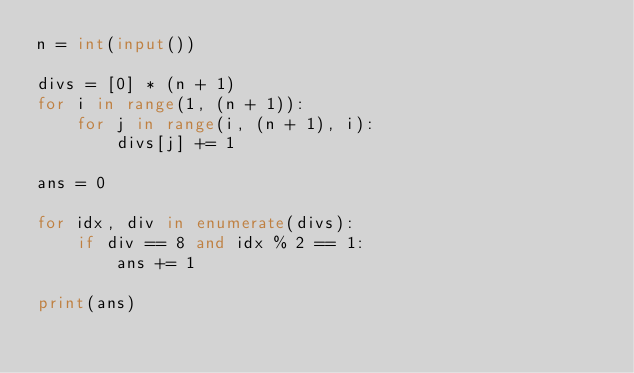Convert code to text. <code><loc_0><loc_0><loc_500><loc_500><_Python_>n = int(input())

divs = [0] * (n + 1)
for i in range(1, (n + 1)):
    for j in range(i, (n + 1), i):
        divs[j] += 1

ans = 0

for idx, div in enumerate(divs):
    if div == 8 and idx % 2 == 1:
        ans += 1

print(ans)
</code> 